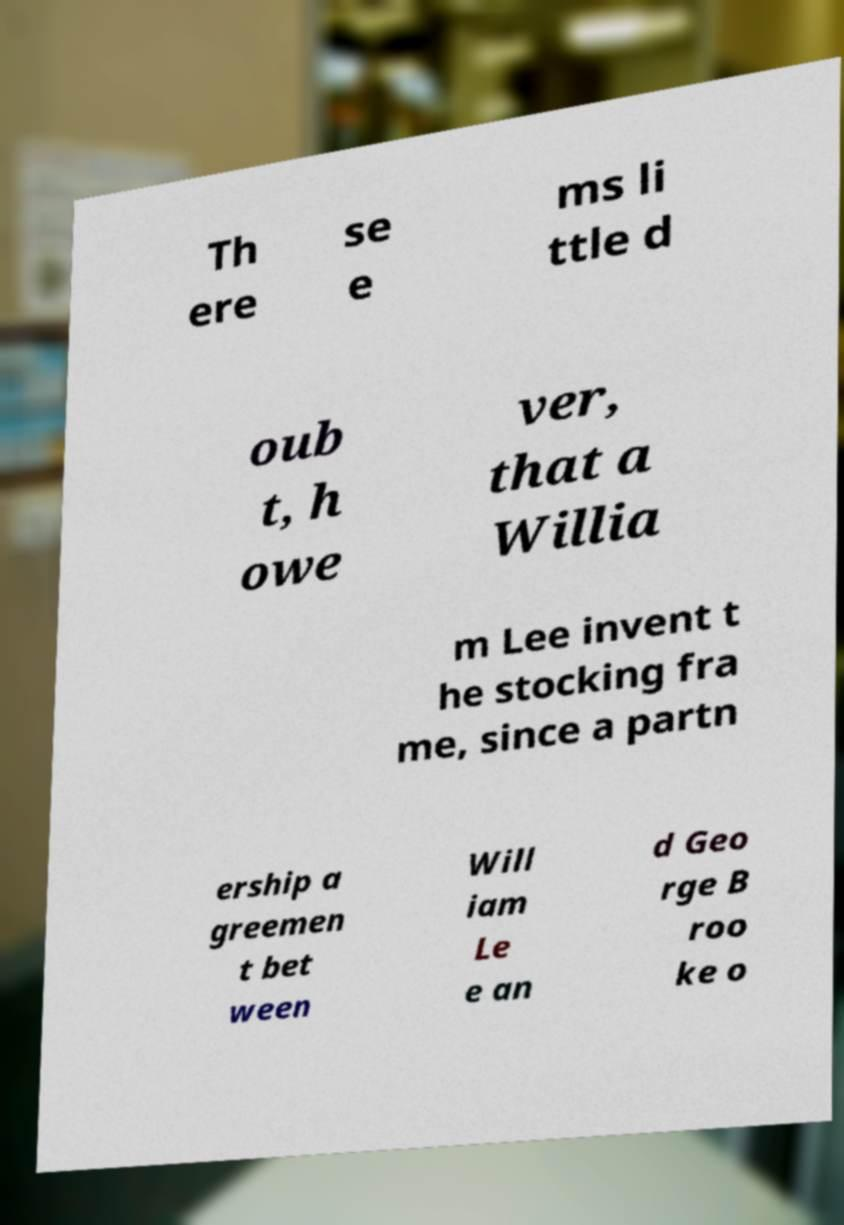Can you read and provide the text displayed in the image?This photo seems to have some interesting text. Can you extract and type it out for me? Th ere se e ms li ttle d oub t, h owe ver, that a Willia m Lee invent t he stocking fra me, since a partn ership a greemen t bet ween Will iam Le e an d Geo rge B roo ke o 